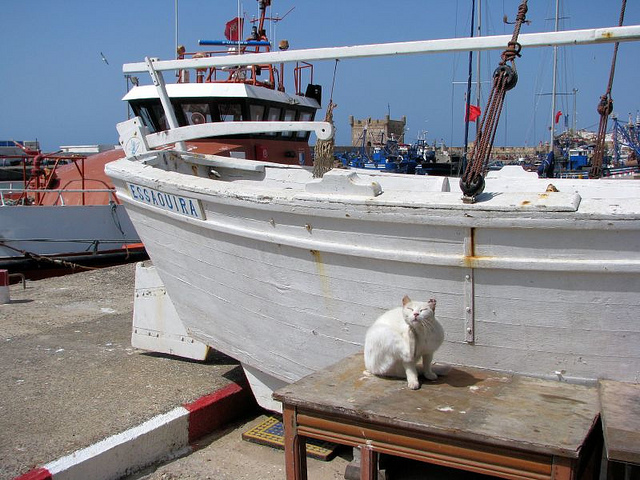Identify the text contained in this image. ESSAOUIRA 